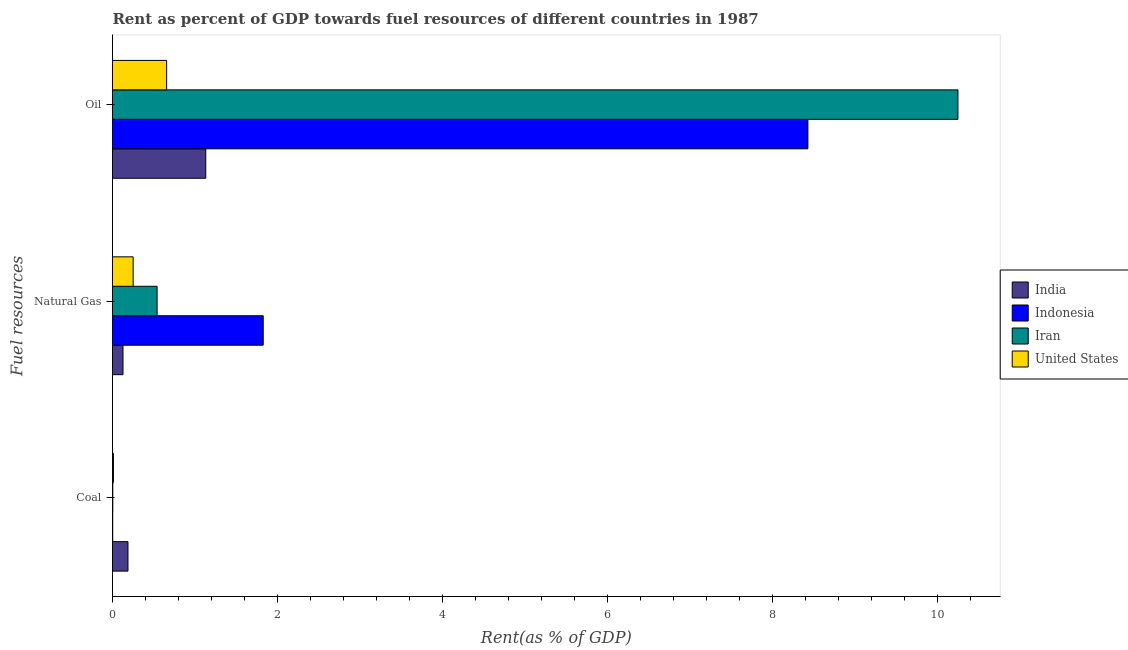How many groups of bars are there?
Provide a succinct answer. 3. Are the number of bars per tick equal to the number of legend labels?
Provide a short and direct response. Yes. How many bars are there on the 1st tick from the top?
Offer a very short reply. 4. How many bars are there on the 1st tick from the bottom?
Your answer should be very brief. 4. What is the label of the 3rd group of bars from the top?
Provide a short and direct response. Coal. What is the rent towards oil in India?
Keep it short and to the point. 1.13. Across all countries, what is the maximum rent towards coal?
Provide a succinct answer. 0.19. Across all countries, what is the minimum rent towards coal?
Provide a succinct answer. 0. In which country was the rent towards oil maximum?
Provide a succinct answer. Iran. In which country was the rent towards oil minimum?
Provide a short and direct response. United States. What is the total rent towards oil in the graph?
Provide a short and direct response. 20.45. What is the difference between the rent towards natural gas in India and that in Iran?
Ensure brevity in your answer.  -0.41. What is the difference between the rent towards oil in Iran and the rent towards natural gas in India?
Give a very brief answer. 10.12. What is the average rent towards coal per country?
Offer a terse response. 0.05. What is the difference between the rent towards natural gas and rent towards oil in Indonesia?
Your response must be concise. -6.6. What is the ratio of the rent towards natural gas in Indonesia to that in Iran?
Provide a short and direct response. 3.38. Is the rent towards natural gas in Iran less than that in Indonesia?
Ensure brevity in your answer.  Yes. What is the difference between the highest and the second highest rent towards natural gas?
Provide a succinct answer. 1.29. What is the difference between the highest and the lowest rent towards coal?
Give a very brief answer. 0.18. What does the 4th bar from the top in Coal represents?
Make the answer very short. India. What does the 4th bar from the bottom in Coal represents?
Make the answer very short. United States. How many bars are there?
Make the answer very short. 12. How many countries are there in the graph?
Your answer should be very brief. 4. Are the values on the major ticks of X-axis written in scientific E-notation?
Your answer should be very brief. No. Does the graph contain any zero values?
Keep it short and to the point. No. Where does the legend appear in the graph?
Provide a succinct answer. Center right. What is the title of the graph?
Your answer should be compact. Rent as percent of GDP towards fuel resources of different countries in 1987. What is the label or title of the X-axis?
Your response must be concise. Rent(as % of GDP). What is the label or title of the Y-axis?
Make the answer very short. Fuel resources. What is the Rent(as % of GDP) in India in Coal?
Give a very brief answer. 0.19. What is the Rent(as % of GDP) in Indonesia in Coal?
Keep it short and to the point. 0. What is the Rent(as % of GDP) of Iran in Coal?
Your answer should be compact. 0. What is the Rent(as % of GDP) of United States in Coal?
Offer a very short reply. 0.01. What is the Rent(as % of GDP) in India in Natural Gas?
Offer a very short reply. 0.13. What is the Rent(as % of GDP) in Indonesia in Natural Gas?
Your answer should be compact. 1.83. What is the Rent(as % of GDP) in Iran in Natural Gas?
Offer a terse response. 0.54. What is the Rent(as % of GDP) in United States in Natural Gas?
Your answer should be very brief. 0.25. What is the Rent(as % of GDP) in India in Oil?
Give a very brief answer. 1.13. What is the Rent(as % of GDP) in Indonesia in Oil?
Keep it short and to the point. 8.42. What is the Rent(as % of GDP) of Iran in Oil?
Provide a succinct answer. 10.24. What is the Rent(as % of GDP) in United States in Oil?
Make the answer very short. 0.66. Across all Fuel resources, what is the maximum Rent(as % of GDP) in India?
Make the answer very short. 1.13. Across all Fuel resources, what is the maximum Rent(as % of GDP) in Indonesia?
Keep it short and to the point. 8.42. Across all Fuel resources, what is the maximum Rent(as % of GDP) of Iran?
Provide a succinct answer. 10.24. Across all Fuel resources, what is the maximum Rent(as % of GDP) of United States?
Ensure brevity in your answer.  0.66. Across all Fuel resources, what is the minimum Rent(as % of GDP) of India?
Your answer should be compact. 0.13. Across all Fuel resources, what is the minimum Rent(as % of GDP) in Indonesia?
Your answer should be very brief. 0. Across all Fuel resources, what is the minimum Rent(as % of GDP) of Iran?
Offer a very short reply. 0. Across all Fuel resources, what is the minimum Rent(as % of GDP) in United States?
Make the answer very short. 0.01. What is the total Rent(as % of GDP) of India in the graph?
Give a very brief answer. 1.44. What is the total Rent(as % of GDP) in Indonesia in the graph?
Your response must be concise. 10.25. What is the total Rent(as % of GDP) of Iran in the graph?
Make the answer very short. 10.79. What is the total Rent(as % of GDP) in United States in the graph?
Ensure brevity in your answer.  0.92. What is the difference between the Rent(as % of GDP) of India in Coal and that in Natural Gas?
Your answer should be compact. 0.06. What is the difference between the Rent(as % of GDP) of Indonesia in Coal and that in Natural Gas?
Ensure brevity in your answer.  -1.82. What is the difference between the Rent(as % of GDP) in Iran in Coal and that in Natural Gas?
Keep it short and to the point. -0.54. What is the difference between the Rent(as % of GDP) in United States in Coal and that in Natural Gas?
Offer a very short reply. -0.24. What is the difference between the Rent(as % of GDP) of India in Coal and that in Oil?
Ensure brevity in your answer.  -0.94. What is the difference between the Rent(as % of GDP) of Indonesia in Coal and that in Oil?
Offer a terse response. -8.42. What is the difference between the Rent(as % of GDP) of Iran in Coal and that in Oil?
Offer a terse response. -10.24. What is the difference between the Rent(as % of GDP) of United States in Coal and that in Oil?
Your answer should be very brief. -0.64. What is the difference between the Rent(as % of GDP) of India in Natural Gas and that in Oil?
Your answer should be very brief. -1. What is the difference between the Rent(as % of GDP) in Indonesia in Natural Gas and that in Oil?
Your answer should be very brief. -6.6. What is the difference between the Rent(as % of GDP) of Iran in Natural Gas and that in Oil?
Provide a succinct answer. -9.7. What is the difference between the Rent(as % of GDP) of United States in Natural Gas and that in Oil?
Make the answer very short. -0.41. What is the difference between the Rent(as % of GDP) in India in Coal and the Rent(as % of GDP) in Indonesia in Natural Gas?
Keep it short and to the point. -1.64. What is the difference between the Rent(as % of GDP) in India in Coal and the Rent(as % of GDP) in Iran in Natural Gas?
Keep it short and to the point. -0.35. What is the difference between the Rent(as % of GDP) in India in Coal and the Rent(as % of GDP) in United States in Natural Gas?
Your response must be concise. -0.06. What is the difference between the Rent(as % of GDP) of Indonesia in Coal and the Rent(as % of GDP) of Iran in Natural Gas?
Offer a terse response. -0.54. What is the difference between the Rent(as % of GDP) in Indonesia in Coal and the Rent(as % of GDP) in United States in Natural Gas?
Your response must be concise. -0.25. What is the difference between the Rent(as % of GDP) of Iran in Coal and the Rent(as % of GDP) of United States in Natural Gas?
Your answer should be very brief. -0.25. What is the difference between the Rent(as % of GDP) of India in Coal and the Rent(as % of GDP) of Indonesia in Oil?
Provide a short and direct response. -8.24. What is the difference between the Rent(as % of GDP) in India in Coal and the Rent(as % of GDP) in Iran in Oil?
Your answer should be very brief. -10.06. What is the difference between the Rent(as % of GDP) in India in Coal and the Rent(as % of GDP) in United States in Oil?
Your answer should be very brief. -0.47. What is the difference between the Rent(as % of GDP) of Indonesia in Coal and the Rent(as % of GDP) of Iran in Oil?
Your answer should be compact. -10.24. What is the difference between the Rent(as % of GDP) of Indonesia in Coal and the Rent(as % of GDP) of United States in Oil?
Your answer should be very brief. -0.65. What is the difference between the Rent(as % of GDP) of Iran in Coal and the Rent(as % of GDP) of United States in Oil?
Make the answer very short. -0.65. What is the difference between the Rent(as % of GDP) in India in Natural Gas and the Rent(as % of GDP) in Indonesia in Oil?
Keep it short and to the point. -8.3. What is the difference between the Rent(as % of GDP) in India in Natural Gas and the Rent(as % of GDP) in Iran in Oil?
Keep it short and to the point. -10.12. What is the difference between the Rent(as % of GDP) of India in Natural Gas and the Rent(as % of GDP) of United States in Oil?
Make the answer very short. -0.53. What is the difference between the Rent(as % of GDP) of Indonesia in Natural Gas and the Rent(as % of GDP) of Iran in Oil?
Provide a short and direct response. -8.42. What is the difference between the Rent(as % of GDP) of Indonesia in Natural Gas and the Rent(as % of GDP) of United States in Oil?
Your answer should be compact. 1.17. What is the difference between the Rent(as % of GDP) of Iran in Natural Gas and the Rent(as % of GDP) of United States in Oil?
Your response must be concise. -0.12. What is the average Rent(as % of GDP) in India per Fuel resources?
Your answer should be compact. 0.48. What is the average Rent(as % of GDP) of Indonesia per Fuel resources?
Provide a short and direct response. 3.42. What is the average Rent(as % of GDP) in Iran per Fuel resources?
Keep it short and to the point. 3.6. What is the average Rent(as % of GDP) of United States per Fuel resources?
Offer a terse response. 0.31. What is the difference between the Rent(as % of GDP) of India and Rent(as % of GDP) of Indonesia in Coal?
Offer a terse response. 0.18. What is the difference between the Rent(as % of GDP) of India and Rent(as % of GDP) of Iran in Coal?
Ensure brevity in your answer.  0.18. What is the difference between the Rent(as % of GDP) of India and Rent(as % of GDP) of United States in Coal?
Give a very brief answer. 0.18. What is the difference between the Rent(as % of GDP) of Indonesia and Rent(as % of GDP) of Iran in Coal?
Provide a short and direct response. -0. What is the difference between the Rent(as % of GDP) in Indonesia and Rent(as % of GDP) in United States in Coal?
Offer a terse response. -0.01. What is the difference between the Rent(as % of GDP) of Iran and Rent(as % of GDP) of United States in Coal?
Ensure brevity in your answer.  -0.01. What is the difference between the Rent(as % of GDP) in India and Rent(as % of GDP) in Indonesia in Natural Gas?
Provide a succinct answer. -1.7. What is the difference between the Rent(as % of GDP) in India and Rent(as % of GDP) in Iran in Natural Gas?
Offer a very short reply. -0.41. What is the difference between the Rent(as % of GDP) in India and Rent(as % of GDP) in United States in Natural Gas?
Make the answer very short. -0.12. What is the difference between the Rent(as % of GDP) of Indonesia and Rent(as % of GDP) of Iran in Natural Gas?
Provide a succinct answer. 1.29. What is the difference between the Rent(as % of GDP) in Indonesia and Rent(as % of GDP) in United States in Natural Gas?
Offer a very short reply. 1.58. What is the difference between the Rent(as % of GDP) in Iran and Rent(as % of GDP) in United States in Natural Gas?
Provide a short and direct response. 0.29. What is the difference between the Rent(as % of GDP) in India and Rent(as % of GDP) in Indonesia in Oil?
Offer a terse response. -7.29. What is the difference between the Rent(as % of GDP) in India and Rent(as % of GDP) in Iran in Oil?
Your answer should be very brief. -9.11. What is the difference between the Rent(as % of GDP) in India and Rent(as % of GDP) in United States in Oil?
Offer a very short reply. 0.47. What is the difference between the Rent(as % of GDP) of Indonesia and Rent(as % of GDP) of Iran in Oil?
Offer a terse response. -1.82. What is the difference between the Rent(as % of GDP) in Indonesia and Rent(as % of GDP) in United States in Oil?
Provide a short and direct response. 7.77. What is the difference between the Rent(as % of GDP) in Iran and Rent(as % of GDP) in United States in Oil?
Offer a very short reply. 9.59. What is the ratio of the Rent(as % of GDP) of India in Coal to that in Natural Gas?
Ensure brevity in your answer.  1.47. What is the ratio of the Rent(as % of GDP) in Indonesia in Coal to that in Natural Gas?
Make the answer very short. 0. What is the ratio of the Rent(as % of GDP) of Iran in Coal to that in Natural Gas?
Provide a short and direct response. 0.01. What is the ratio of the Rent(as % of GDP) in United States in Coal to that in Natural Gas?
Keep it short and to the point. 0.05. What is the ratio of the Rent(as % of GDP) in India in Coal to that in Oil?
Give a very brief answer. 0.17. What is the ratio of the Rent(as % of GDP) of Iran in Coal to that in Oil?
Offer a very short reply. 0. What is the ratio of the Rent(as % of GDP) of United States in Coal to that in Oil?
Make the answer very short. 0.02. What is the ratio of the Rent(as % of GDP) in India in Natural Gas to that in Oil?
Provide a short and direct response. 0.11. What is the ratio of the Rent(as % of GDP) in Indonesia in Natural Gas to that in Oil?
Make the answer very short. 0.22. What is the ratio of the Rent(as % of GDP) of Iran in Natural Gas to that in Oil?
Ensure brevity in your answer.  0.05. What is the ratio of the Rent(as % of GDP) in United States in Natural Gas to that in Oil?
Your answer should be very brief. 0.38. What is the difference between the highest and the second highest Rent(as % of GDP) of India?
Offer a terse response. 0.94. What is the difference between the highest and the second highest Rent(as % of GDP) in Indonesia?
Make the answer very short. 6.6. What is the difference between the highest and the second highest Rent(as % of GDP) of Iran?
Offer a very short reply. 9.7. What is the difference between the highest and the second highest Rent(as % of GDP) of United States?
Give a very brief answer. 0.41. What is the difference between the highest and the lowest Rent(as % of GDP) in Indonesia?
Provide a short and direct response. 8.42. What is the difference between the highest and the lowest Rent(as % of GDP) of Iran?
Keep it short and to the point. 10.24. What is the difference between the highest and the lowest Rent(as % of GDP) of United States?
Provide a succinct answer. 0.64. 